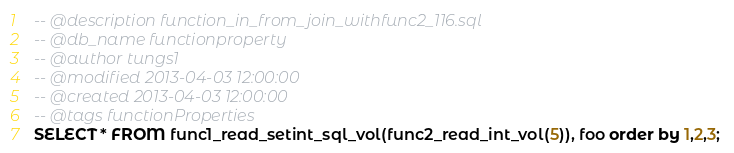<code> <loc_0><loc_0><loc_500><loc_500><_SQL_>-- @description function_in_from_join_withfunc2_116.sql
-- @db_name functionproperty
-- @author tungs1
-- @modified 2013-04-03 12:00:00
-- @created 2013-04-03 12:00:00
-- @tags functionProperties 
SELECT * FROM func1_read_setint_sql_vol(func2_read_int_vol(5)), foo order by 1,2,3; 
</code> 